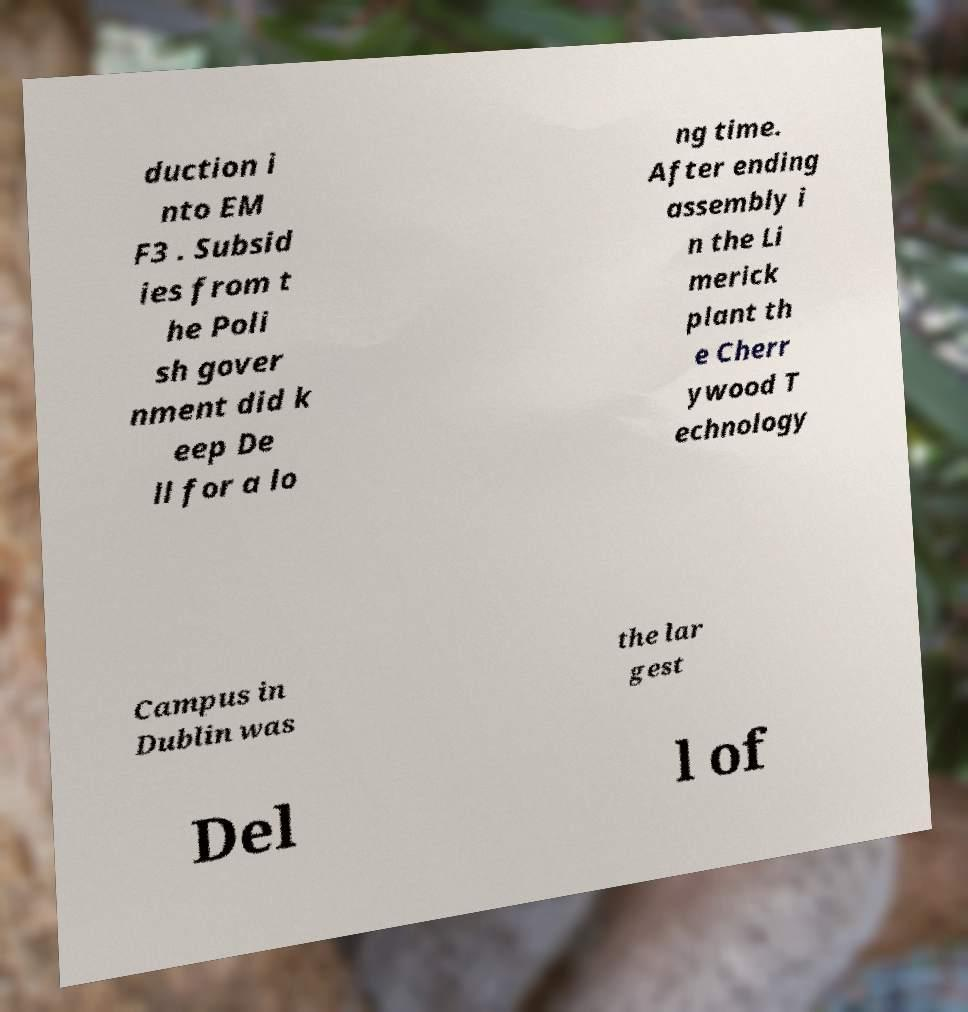Please read and relay the text visible in this image. What does it say? duction i nto EM F3 . Subsid ies from t he Poli sh gover nment did k eep De ll for a lo ng time. After ending assembly i n the Li merick plant th e Cherr ywood T echnology Campus in Dublin was the lar gest Del l of 